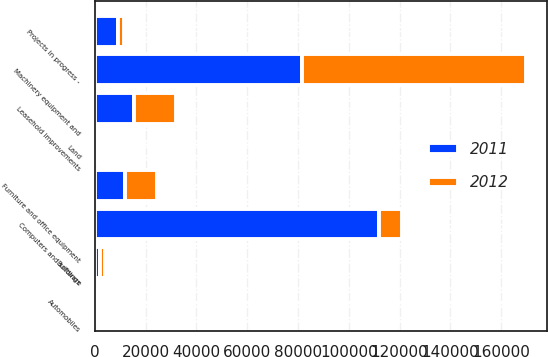Convert chart. <chart><loc_0><loc_0><loc_500><loc_500><stacked_bar_chart><ecel><fcel>Buildings<fcel>Land<fcel>Machinery equipment and<fcel>Furniture and office equipment<fcel>Computers and software<fcel>Automobiles<fcel>Leasehold improvements<fcel>Projects in progress -<nl><fcel>2012<fcel>2134<fcel>504<fcel>88222<fcel>12672<fcel>9135<fcel>18<fcel>16380<fcel>2217<nl><fcel>2011<fcel>2086<fcel>504<fcel>81464<fcel>12003<fcel>111793<fcel>18<fcel>15494<fcel>9135<nl></chart> 